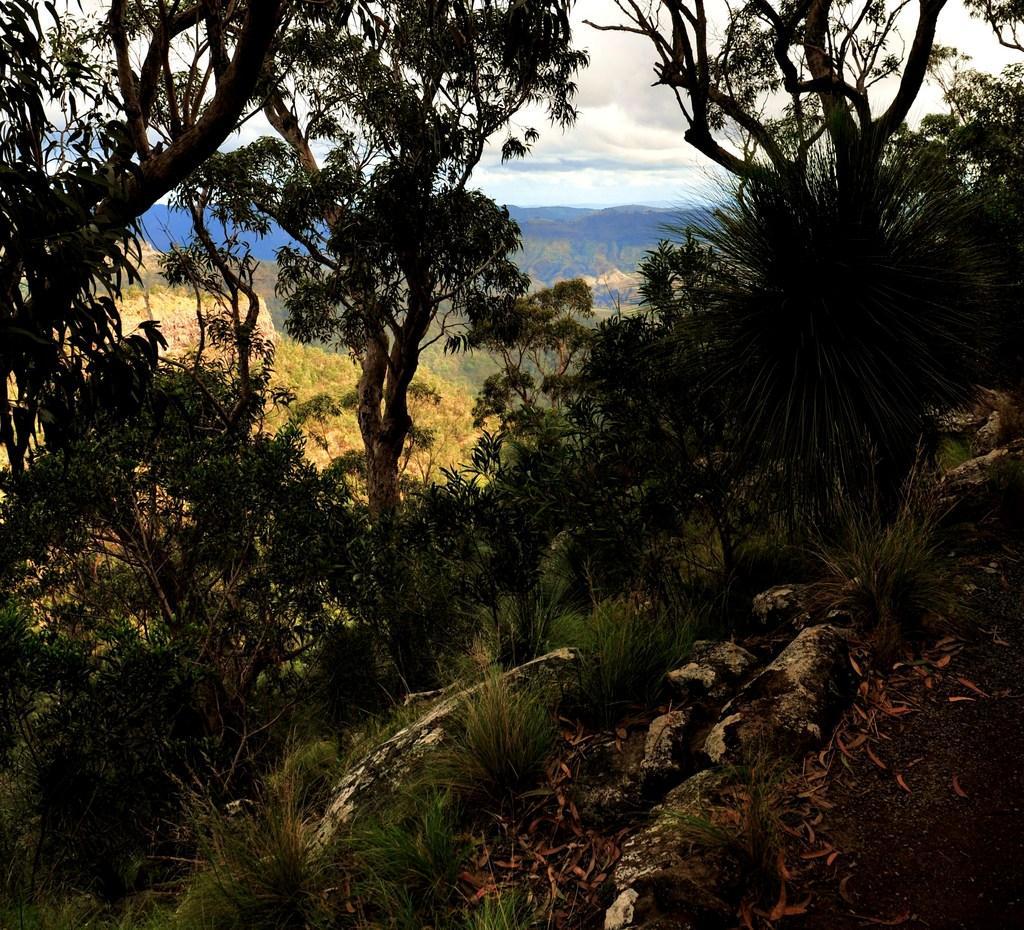Could you give a brief overview of what you see in this image? In this picture we can see some grass and a few leaves on the path. There are some trees and mountains in the background. Sky is cloudy. 